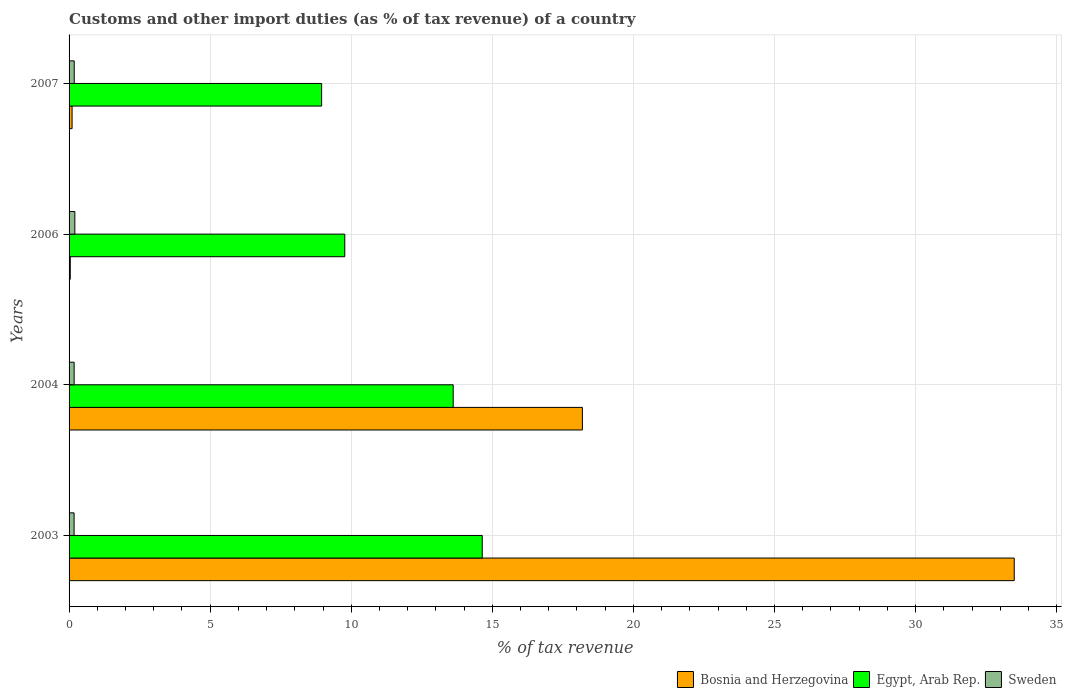How many different coloured bars are there?
Your answer should be very brief. 3. Are the number of bars per tick equal to the number of legend labels?
Your response must be concise. Yes. Are the number of bars on each tick of the Y-axis equal?
Offer a terse response. Yes. How many bars are there on the 2nd tick from the top?
Offer a terse response. 3. How many bars are there on the 3rd tick from the bottom?
Provide a succinct answer. 3. What is the percentage of tax revenue from customs in Sweden in 2003?
Keep it short and to the point. 0.18. Across all years, what is the maximum percentage of tax revenue from customs in Sweden?
Offer a very short reply. 0.2. Across all years, what is the minimum percentage of tax revenue from customs in Egypt, Arab Rep.?
Provide a succinct answer. 8.95. In which year was the percentage of tax revenue from customs in Egypt, Arab Rep. maximum?
Ensure brevity in your answer.  2003. In which year was the percentage of tax revenue from customs in Sweden minimum?
Provide a short and direct response. 2003. What is the total percentage of tax revenue from customs in Bosnia and Herzegovina in the graph?
Keep it short and to the point. 51.84. What is the difference between the percentage of tax revenue from customs in Egypt, Arab Rep. in 2003 and that in 2007?
Your response must be concise. 5.69. What is the difference between the percentage of tax revenue from customs in Egypt, Arab Rep. in 2007 and the percentage of tax revenue from customs in Sweden in 2003?
Your answer should be compact. 8.77. What is the average percentage of tax revenue from customs in Egypt, Arab Rep. per year?
Provide a succinct answer. 11.74. In the year 2003, what is the difference between the percentage of tax revenue from customs in Egypt, Arab Rep. and percentage of tax revenue from customs in Sweden?
Offer a terse response. 14.46. In how many years, is the percentage of tax revenue from customs in Bosnia and Herzegovina greater than 3 %?
Your answer should be very brief. 2. What is the ratio of the percentage of tax revenue from customs in Egypt, Arab Rep. in 2003 to that in 2004?
Offer a terse response. 1.08. Is the percentage of tax revenue from customs in Egypt, Arab Rep. in 2004 less than that in 2006?
Offer a terse response. No. Is the difference between the percentage of tax revenue from customs in Egypt, Arab Rep. in 2003 and 2004 greater than the difference between the percentage of tax revenue from customs in Sweden in 2003 and 2004?
Ensure brevity in your answer.  Yes. What is the difference between the highest and the second highest percentage of tax revenue from customs in Bosnia and Herzegovina?
Your answer should be very brief. 15.3. What is the difference between the highest and the lowest percentage of tax revenue from customs in Egypt, Arab Rep.?
Your answer should be very brief. 5.69. What does the 3rd bar from the top in 2003 represents?
Your answer should be very brief. Bosnia and Herzegovina. What does the 2nd bar from the bottom in 2004 represents?
Offer a very short reply. Egypt, Arab Rep. Is it the case that in every year, the sum of the percentage of tax revenue from customs in Bosnia and Herzegovina and percentage of tax revenue from customs in Sweden is greater than the percentage of tax revenue from customs in Egypt, Arab Rep.?
Provide a succinct answer. No. What is the difference between two consecutive major ticks on the X-axis?
Offer a very short reply. 5. Are the values on the major ticks of X-axis written in scientific E-notation?
Offer a very short reply. No. Does the graph contain grids?
Your answer should be very brief. Yes. How many legend labels are there?
Give a very brief answer. 3. What is the title of the graph?
Offer a terse response. Customs and other import duties (as % of tax revenue) of a country. Does "Zambia" appear as one of the legend labels in the graph?
Offer a terse response. No. What is the label or title of the X-axis?
Give a very brief answer. % of tax revenue. What is the % of tax revenue of Bosnia and Herzegovina in 2003?
Offer a terse response. 33.5. What is the % of tax revenue of Egypt, Arab Rep. in 2003?
Your answer should be compact. 14.64. What is the % of tax revenue of Sweden in 2003?
Give a very brief answer. 0.18. What is the % of tax revenue in Bosnia and Herzegovina in 2004?
Give a very brief answer. 18.19. What is the % of tax revenue in Egypt, Arab Rep. in 2004?
Ensure brevity in your answer.  13.61. What is the % of tax revenue in Sweden in 2004?
Keep it short and to the point. 0.18. What is the % of tax revenue of Bosnia and Herzegovina in 2006?
Offer a terse response. 0.04. What is the % of tax revenue in Egypt, Arab Rep. in 2006?
Offer a terse response. 9.77. What is the % of tax revenue of Sweden in 2006?
Your response must be concise. 0.2. What is the % of tax revenue of Bosnia and Herzegovina in 2007?
Provide a succinct answer. 0.11. What is the % of tax revenue in Egypt, Arab Rep. in 2007?
Ensure brevity in your answer.  8.95. What is the % of tax revenue in Sweden in 2007?
Provide a short and direct response. 0.18. Across all years, what is the maximum % of tax revenue of Bosnia and Herzegovina?
Your answer should be very brief. 33.5. Across all years, what is the maximum % of tax revenue of Egypt, Arab Rep.?
Make the answer very short. 14.64. Across all years, what is the maximum % of tax revenue of Sweden?
Give a very brief answer. 0.2. Across all years, what is the minimum % of tax revenue in Bosnia and Herzegovina?
Keep it short and to the point. 0.04. Across all years, what is the minimum % of tax revenue of Egypt, Arab Rep.?
Provide a succinct answer. 8.95. Across all years, what is the minimum % of tax revenue in Sweden?
Keep it short and to the point. 0.18. What is the total % of tax revenue of Bosnia and Herzegovina in the graph?
Your answer should be very brief. 51.84. What is the total % of tax revenue in Egypt, Arab Rep. in the graph?
Provide a short and direct response. 46.98. What is the total % of tax revenue in Sweden in the graph?
Keep it short and to the point. 0.75. What is the difference between the % of tax revenue of Bosnia and Herzegovina in 2003 and that in 2004?
Give a very brief answer. 15.3. What is the difference between the % of tax revenue in Egypt, Arab Rep. in 2003 and that in 2004?
Your answer should be very brief. 1.03. What is the difference between the % of tax revenue in Sweden in 2003 and that in 2004?
Offer a very short reply. -0. What is the difference between the % of tax revenue in Bosnia and Herzegovina in 2003 and that in 2006?
Your answer should be very brief. 33.45. What is the difference between the % of tax revenue in Egypt, Arab Rep. in 2003 and that in 2006?
Your answer should be very brief. 4.87. What is the difference between the % of tax revenue in Sweden in 2003 and that in 2006?
Ensure brevity in your answer.  -0.03. What is the difference between the % of tax revenue of Bosnia and Herzegovina in 2003 and that in 2007?
Give a very brief answer. 33.39. What is the difference between the % of tax revenue in Egypt, Arab Rep. in 2003 and that in 2007?
Your answer should be compact. 5.69. What is the difference between the % of tax revenue of Sweden in 2003 and that in 2007?
Ensure brevity in your answer.  -0. What is the difference between the % of tax revenue of Bosnia and Herzegovina in 2004 and that in 2006?
Your answer should be very brief. 18.15. What is the difference between the % of tax revenue of Egypt, Arab Rep. in 2004 and that in 2006?
Keep it short and to the point. 3.84. What is the difference between the % of tax revenue in Sweden in 2004 and that in 2006?
Your answer should be very brief. -0.02. What is the difference between the % of tax revenue in Bosnia and Herzegovina in 2004 and that in 2007?
Your answer should be compact. 18.09. What is the difference between the % of tax revenue in Egypt, Arab Rep. in 2004 and that in 2007?
Your response must be concise. 4.66. What is the difference between the % of tax revenue of Sweden in 2004 and that in 2007?
Ensure brevity in your answer.  -0. What is the difference between the % of tax revenue of Bosnia and Herzegovina in 2006 and that in 2007?
Your response must be concise. -0.06. What is the difference between the % of tax revenue in Egypt, Arab Rep. in 2006 and that in 2007?
Your answer should be compact. 0.82. What is the difference between the % of tax revenue of Sweden in 2006 and that in 2007?
Ensure brevity in your answer.  0.02. What is the difference between the % of tax revenue of Bosnia and Herzegovina in 2003 and the % of tax revenue of Egypt, Arab Rep. in 2004?
Give a very brief answer. 19.88. What is the difference between the % of tax revenue of Bosnia and Herzegovina in 2003 and the % of tax revenue of Sweden in 2004?
Your response must be concise. 33.32. What is the difference between the % of tax revenue of Egypt, Arab Rep. in 2003 and the % of tax revenue of Sweden in 2004?
Provide a short and direct response. 14.46. What is the difference between the % of tax revenue of Bosnia and Herzegovina in 2003 and the % of tax revenue of Egypt, Arab Rep. in 2006?
Ensure brevity in your answer.  23.73. What is the difference between the % of tax revenue of Bosnia and Herzegovina in 2003 and the % of tax revenue of Sweden in 2006?
Offer a terse response. 33.29. What is the difference between the % of tax revenue in Egypt, Arab Rep. in 2003 and the % of tax revenue in Sweden in 2006?
Ensure brevity in your answer.  14.44. What is the difference between the % of tax revenue in Bosnia and Herzegovina in 2003 and the % of tax revenue in Egypt, Arab Rep. in 2007?
Ensure brevity in your answer.  24.55. What is the difference between the % of tax revenue in Bosnia and Herzegovina in 2003 and the % of tax revenue in Sweden in 2007?
Provide a succinct answer. 33.31. What is the difference between the % of tax revenue in Egypt, Arab Rep. in 2003 and the % of tax revenue in Sweden in 2007?
Offer a terse response. 14.46. What is the difference between the % of tax revenue of Bosnia and Herzegovina in 2004 and the % of tax revenue of Egypt, Arab Rep. in 2006?
Provide a short and direct response. 8.42. What is the difference between the % of tax revenue of Bosnia and Herzegovina in 2004 and the % of tax revenue of Sweden in 2006?
Ensure brevity in your answer.  17.99. What is the difference between the % of tax revenue of Egypt, Arab Rep. in 2004 and the % of tax revenue of Sweden in 2006?
Keep it short and to the point. 13.41. What is the difference between the % of tax revenue of Bosnia and Herzegovina in 2004 and the % of tax revenue of Egypt, Arab Rep. in 2007?
Your answer should be compact. 9.24. What is the difference between the % of tax revenue in Bosnia and Herzegovina in 2004 and the % of tax revenue in Sweden in 2007?
Your response must be concise. 18.01. What is the difference between the % of tax revenue in Egypt, Arab Rep. in 2004 and the % of tax revenue in Sweden in 2007?
Give a very brief answer. 13.43. What is the difference between the % of tax revenue of Bosnia and Herzegovina in 2006 and the % of tax revenue of Egypt, Arab Rep. in 2007?
Offer a very short reply. -8.91. What is the difference between the % of tax revenue of Bosnia and Herzegovina in 2006 and the % of tax revenue of Sweden in 2007?
Offer a very short reply. -0.14. What is the difference between the % of tax revenue of Egypt, Arab Rep. in 2006 and the % of tax revenue of Sweden in 2007?
Keep it short and to the point. 9.59. What is the average % of tax revenue of Bosnia and Herzegovina per year?
Provide a succinct answer. 12.96. What is the average % of tax revenue of Egypt, Arab Rep. per year?
Provide a short and direct response. 11.74. What is the average % of tax revenue of Sweden per year?
Your response must be concise. 0.19. In the year 2003, what is the difference between the % of tax revenue of Bosnia and Herzegovina and % of tax revenue of Egypt, Arab Rep.?
Your answer should be compact. 18.85. In the year 2003, what is the difference between the % of tax revenue in Bosnia and Herzegovina and % of tax revenue in Sweden?
Your answer should be very brief. 33.32. In the year 2003, what is the difference between the % of tax revenue in Egypt, Arab Rep. and % of tax revenue in Sweden?
Offer a very short reply. 14.46. In the year 2004, what is the difference between the % of tax revenue of Bosnia and Herzegovina and % of tax revenue of Egypt, Arab Rep.?
Offer a terse response. 4.58. In the year 2004, what is the difference between the % of tax revenue of Bosnia and Herzegovina and % of tax revenue of Sweden?
Offer a terse response. 18.01. In the year 2004, what is the difference between the % of tax revenue in Egypt, Arab Rep. and % of tax revenue in Sweden?
Make the answer very short. 13.43. In the year 2006, what is the difference between the % of tax revenue in Bosnia and Herzegovina and % of tax revenue in Egypt, Arab Rep.?
Keep it short and to the point. -9.73. In the year 2006, what is the difference between the % of tax revenue in Bosnia and Herzegovina and % of tax revenue in Sweden?
Ensure brevity in your answer.  -0.16. In the year 2006, what is the difference between the % of tax revenue of Egypt, Arab Rep. and % of tax revenue of Sweden?
Offer a very short reply. 9.57. In the year 2007, what is the difference between the % of tax revenue of Bosnia and Herzegovina and % of tax revenue of Egypt, Arab Rep.?
Give a very brief answer. -8.84. In the year 2007, what is the difference between the % of tax revenue in Bosnia and Herzegovina and % of tax revenue in Sweden?
Your answer should be compact. -0.08. In the year 2007, what is the difference between the % of tax revenue of Egypt, Arab Rep. and % of tax revenue of Sweden?
Provide a short and direct response. 8.77. What is the ratio of the % of tax revenue of Bosnia and Herzegovina in 2003 to that in 2004?
Give a very brief answer. 1.84. What is the ratio of the % of tax revenue in Egypt, Arab Rep. in 2003 to that in 2004?
Your response must be concise. 1.08. What is the ratio of the % of tax revenue in Sweden in 2003 to that in 2004?
Keep it short and to the point. 0.99. What is the ratio of the % of tax revenue in Bosnia and Herzegovina in 2003 to that in 2006?
Provide a short and direct response. 785.11. What is the ratio of the % of tax revenue in Egypt, Arab Rep. in 2003 to that in 2006?
Provide a short and direct response. 1.5. What is the ratio of the % of tax revenue in Sweden in 2003 to that in 2006?
Offer a very short reply. 0.87. What is the ratio of the % of tax revenue in Bosnia and Herzegovina in 2003 to that in 2007?
Offer a very short reply. 313.5. What is the ratio of the % of tax revenue in Egypt, Arab Rep. in 2003 to that in 2007?
Your response must be concise. 1.64. What is the ratio of the % of tax revenue in Sweden in 2003 to that in 2007?
Keep it short and to the point. 0.98. What is the ratio of the % of tax revenue of Bosnia and Herzegovina in 2004 to that in 2006?
Provide a short and direct response. 426.4. What is the ratio of the % of tax revenue in Egypt, Arab Rep. in 2004 to that in 2006?
Provide a succinct answer. 1.39. What is the ratio of the % of tax revenue of Sweden in 2004 to that in 2006?
Give a very brief answer. 0.88. What is the ratio of the % of tax revenue of Bosnia and Herzegovina in 2004 to that in 2007?
Offer a very short reply. 170.26. What is the ratio of the % of tax revenue of Egypt, Arab Rep. in 2004 to that in 2007?
Offer a very short reply. 1.52. What is the ratio of the % of tax revenue in Sweden in 2004 to that in 2007?
Ensure brevity in your answer.  0.99. What is the ratio of the % of tax revenue of Bosnia and Herzegovina in 2006 to that in 2007?
Make the answer very short. 0.4. What is the ratio of the % of tax revenue in Egypt, Arab Rep. in 2006 to that in 2007?
Keep it short and to the point. 1.09. What is the ratio of the % of tax revenue in Sweden in 2006 to that in 2007?
Your answer should be compact. 1.12. What is the difference between the highest and the second highest % of tax revenue in Bosnia and Herzegovina?
Your answer should be very brief. 15.3. What is the difference between the highest and the second highest % of tax revenue in Egypt, Arab Rep.?
Ensure brevity in your answer.  1.03. What is the difference between the highest and the second highest % of tax revenue in Sweden?
Ensure brevity in your answer.  0.02. What is the difference between the highest and the lowest % of tax revenue in Bosnia and Herzegovina?
Keep it short and to the point. 33.45. What is the difference between the highest and the lowest % of tax revenue in Egypt, Arab Rep.?
Provide a short and direct response. 5.69. What is the difference between the highest and the lowest % of tax revenue of Sweden?
Your answer should be very brief. 0.03. 